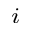<formula> <loc_0><loc_0><loc_500><loc_500>_ { i }</formula> 